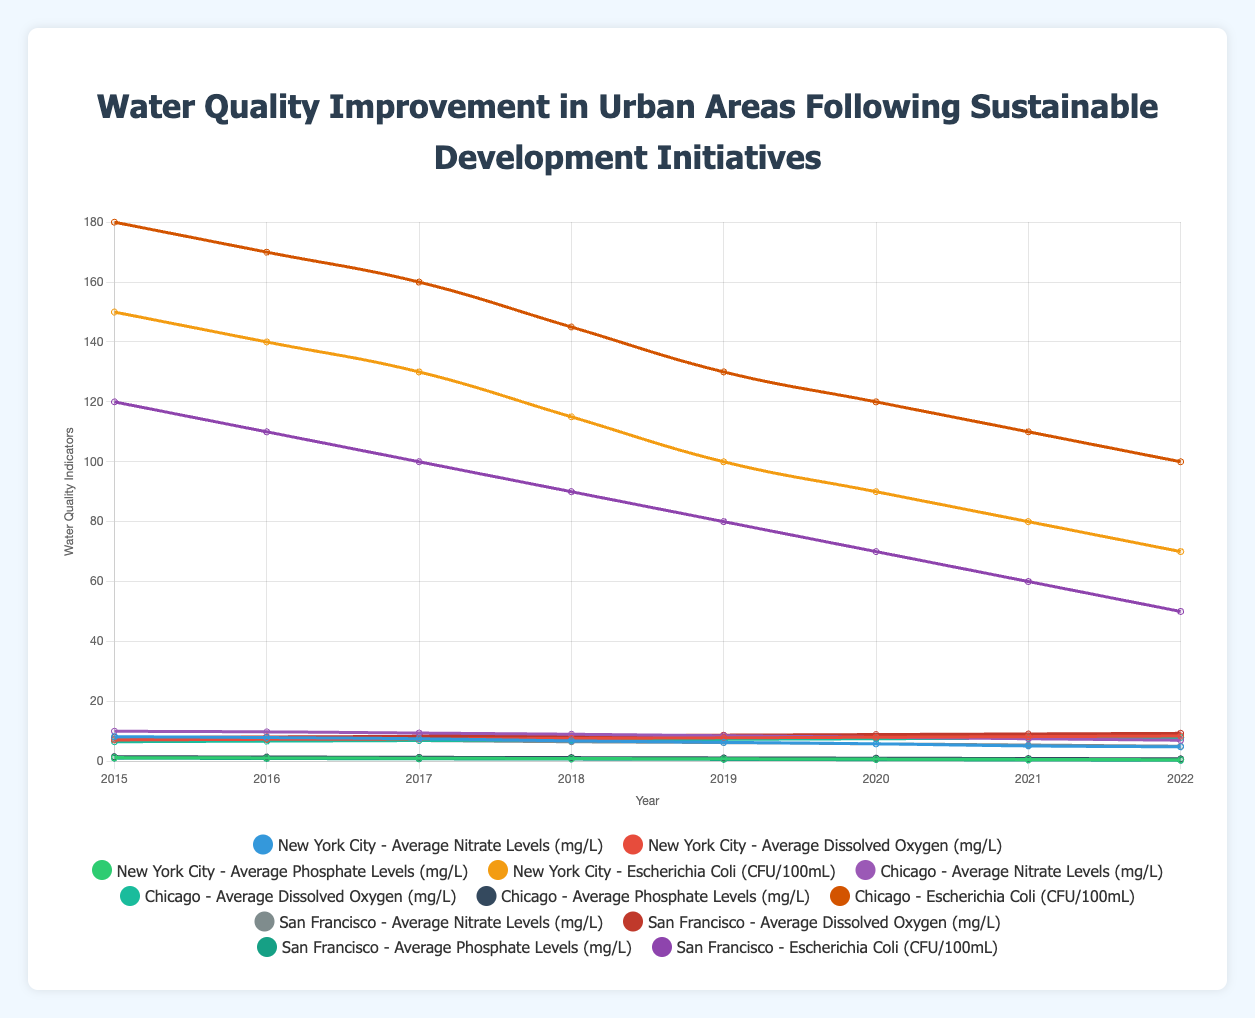How have the average nitrate levels in New York City changed from 2015 to 2022? The line chart indicates a noticeable decline in nitrate levels in New York City over the years. Starting from 8.2 mg/L in 2015, the levels consistently decrease to 4.8 mg/L in 2022.
Answer: Decreased by 3.4 mg/L Which city had the highest average dissolved oxygen level in 2022, and what was the value? By examining the lines representing dissolved oxygen levels for each city, San Francisco had the highest value in 2022, reaching 9.3 mg/L.
Answer: San Francisco, 9.3 mg/L Between 2018 and 2020, how much did the average phosphate levels decrease in Chicago? The chart shows a drop from 1.2 mg/L in 2018 to 1.0 mg/L in 2020 for Chicago. The difference is calculated as 1.2 - 1.0 = 0.2 mg/L.
Answer: 0.2 mg/L Compare the trends in Escherichia Coli levels in New York City and Chicago from 2015 to 2022. Both cities show decreasing trends. In New York City, levels drop from 150 CFU/100mL to 70 CFU/100mL. Similarly, Chicago sees a decline from 180 CFU/100mL to 100 CFU/100mL. Although both cities improved, Chicago had a higher starting point and larger reduction.
Answer: Both decreased, bigger reduction in Chicago What is the average value of nitrate levels in San Francisco over the given years? Summing up San Francisco's nitrate levels from 2015 to 2022: (7.5 + 7.2 + 6.9 + 6.5 + 6.2 + 5.8 + 5.4 + 5.0) = 50.5. The average is 50.5 / 8 = 6.31 mg/L.
Answer: 6.31 mg/L Which indicator had the greatest percentage decrease in New York City from 2015 to 2022? To find the greatest percentage decrease: 
- Nitrate: ((8.2 - 4.8) / 8.2) * 100 ≈ 41.5%
- Phosphate: ((1.2 - 0.5) / 1.2) * 100 ≈ 58.3%
- E. Coli: ((150 - 70) / 150) * 100 ≈ 53.3%
Phosphate had the greatest percentage decrease at approximately 58.3%.
Answer: Phosphate, 58.3% What year did Chicago’s average dissolved oxygen level exceed 7.0 mg/L for the first time? The data for Chicago shows that dissolved oxygen levels surpassed 7.0 mg/L in 2019 when it reached 7.1 mg/L.
Answer: 2019 How do the nitrate level trends in New York City and San Francisco compare from 2015 to 2022? Both cities exhibit a decreasing trend in nitrate levels. The specific values show New York City started at 8.2 mg/L and ended at 4.8 mg/L, while San Francisco began at 7.5 mg/L and ended at 5.0 mg/L. Although both have reductions, NYC had a more significant decrease in absolute values.
Answer: Both decreasing, NYC had a more significant decrease What is the overall trend in average dissolved oxygen levels in all three cities? The line chart for each city shows increasing trends in dissolved oxygen. NY increased from 7.1 mg/L to 8.4 mg/L, Chicago from 6.5 mg/L to 7.9 mg/L, and SF from 8.0 mg/L to 9.3 mg/L. Each city shows an upward trend from 2015 to 2022.
Answer: Increasing in all cities What year did the average phosphate levels in San Francisco fall below 0.5 mg/L? According to the chart, San Francisco’s phosphate levels fall below 0.5 mg/L in 2020 when it reached 0.4 mg/L.
Answer: 2020 